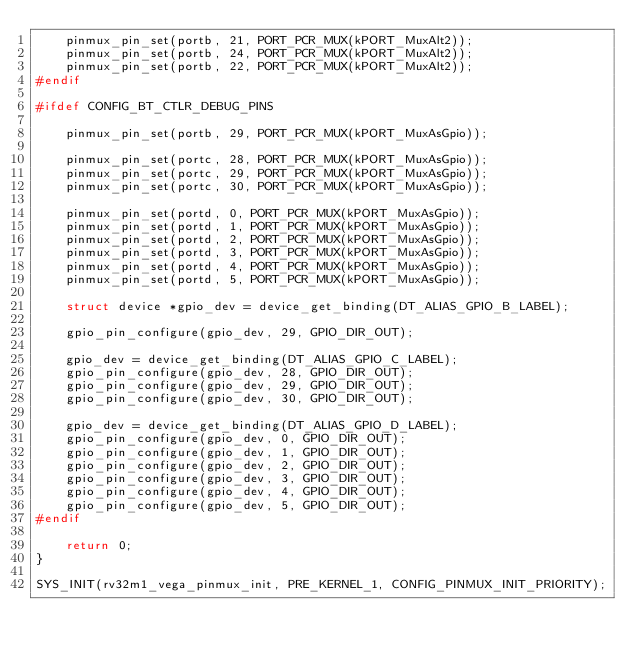Convert code to text. <code><loc_0><loc_0><loc_500><loc_500><_C_>	pinmux_pin_set(portb, 21, PORT_PCR_MUX(kPORT_MuxAlt2));
	pinmux_pin_set(portb, 24, PORT_PCR_MUX(kPORT_MuxAlt2));
	pinmux_pin_set(portb, 22, PORT_PCR_MUX(kPORT_MuxAlt2));
#endif

#ifdef CONFIG_BT_CTLR_DEBUG_PINS

	pinmux_pin_set(portb, 29, PORT_PCR_MUX(kPORT_MuxAsGpio));

	pinmux_pin_set(portc, 28, PORT_PCR_MUX(kPORT_MuxAsGpio));
	pinmux_pin_set(portc, 29, PORT_PCR_MUX(kPORT_MuxAsGpio));
	pinmux_pin_set(portc, 30, PORT_PCR_MUX(kPORT_MuxAsGpio));

	pinmux_pin_set(portd, 0, PORT_PCR_MUX(kPORT_MuxAsGpio));
	pinmux_pin_set(portd, 1, PORT_PCR_MUX(kPORT_MuxAsGpio));
	pinmux_pin_set(portd, 2, PORT_PCR_MUX(kPORT_MuxAsGpio));
	pinmux_pin_set(portd, 3, PORT_PCR_MUX(kPORT_MuxAsGpio));
	pinmux_pin_set(portd, 4, PORT_PCR_MUX(kPORT_MuxAsGpio));
	pinmux_pin_set(portd, 5, PORT_PCR_MUX(kPORT_MuxAsGpio));

	struct device *gpio_dev = device_get_binding(DT_ALIAS_GPIO_B_LABEL);

	gpio_pin_configure(gpio_dev, 29, GPIO_DIR_OUT);

	gpio_dev = device_get_binding(DT_ALIAS_GPIO_C_LABEL);
	gpio_pin_configure(gpio_dev, 28, GPIO_DIR_OUT);
	gpio_pin_configure(gpio_dev, 29, GPIO_DIR_OUT);
	gpio_pin_configure(gpio_dev, 30, GPIO_DIR_OUT);

	gpio_dev = device_get_binding(DT_ALIAS_GPIO_D_LABEL);
	gpio_pin_configure(gpio_dev, 0, GPIO_DIR_OUT);
	gpio_pin_configure(gpio_dev, 1, GPIO_DIR_OUT);
	gpio_pin_configure(gpio_dev, 2, GPIO_DIR_OUT);
	gpio_pin_configure(gpio_dev, 3, GPIO_DIR_OUT);
	gpio_pin_configure(gpio_dev, 4, GPIO_DIR_OUT);
	gpio_pin_configure(gpio_dev, 5, GPIO_DIR_OUT);
#endif

	return 0;
}

SYS_INIT(rv32m1_vega_pinmux_init, PRE_KERNEL_1, CONFIG_PINMUX_INIT_PRIORITY);
</code> 